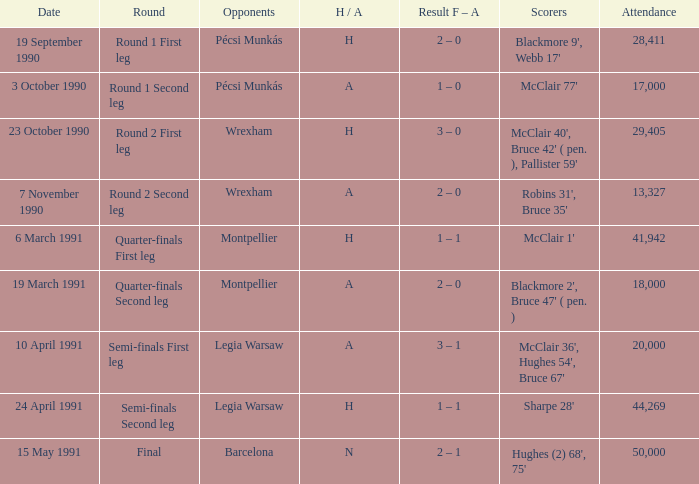What is the competitor's name when the h/a is h with an attendance exceeding 28,411 and sharpe 28' as the one who scores? Legia Warsaw. 